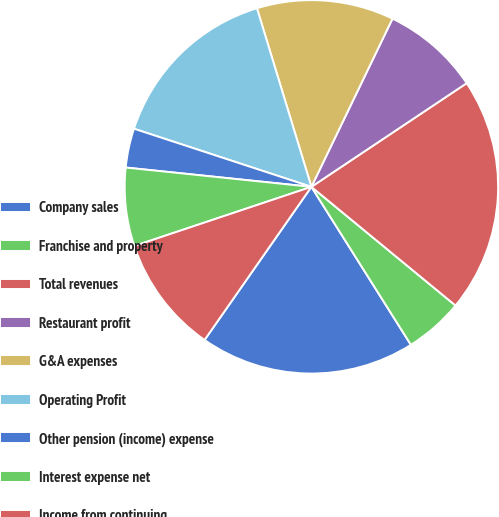Convert chart to OTSL. <chart><loc_0><loc_0><loc_500><loc_500><pie_chart><fcel>Company sales<fcel>Franchise and property<fcel>Total revenues<fcel>Restaurant profit<fcel>G&A expenses<fcel>Operating Profit<fcel>Other pension (income) expense<fcel>Interest expense net<fcel>Income from continuing<nl><fcel>18.64%<fcel>5.09%<fcel>20.33%<fcel>8.48%<fcel>11.86%<fcel>15.25%<fcel>3.39%<fcel>6.78%<fcel>10.17%<nl></chart> 